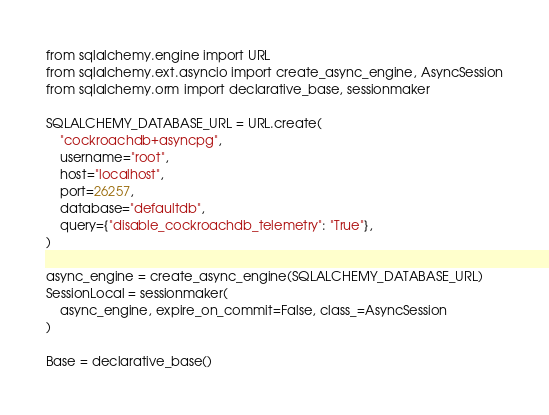Convert code to text. <code><loc_0><loc_0><loc_500><loc_500><_Python_>from sqlalchemy.engine import URL
from sqlalchemy.ext.asyncio import create_async_engine, AsyncSession
from sqlalchemy.orm import declarative_base, sessionmaker

SQLALCHEMY_DATABASE_URL = URL.create(
    "cockroachdb+asyncpg",
    username="root",
    host="localhost",
    port=26257,
    database="defaultdb",
    query={"disable_cockroachdb_telemetry": "True"},
)

async_engine = create_async_engine(SQLALCHEMY_DATABASE_URL)
SessionLocal = sessionmaker(
    async_engine, expire_on_commit=False, class_=AsyncSession
)

Base = declarative_base()
</code> 